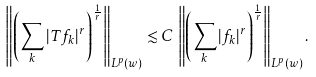<formula> <loc_0><loc_0><loc_500><loc_500>\left \| \left ( \sum _ { k } | T f _ { k } | ^ { r } \right ) ^ { \frac { 1 } { r } } \right \| _ { L ^ { p } ( w ) } \lesssim C \, \left \| \left ( \sum _ { k } | f _ { k } | ^ { r } \right ) ^ { \frac { 1 } { r } } \right \| _ { L ^ { p } ( w ) } .</formula> 